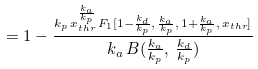Convert formula to latex. <formula><loc_0><loc_0><loc_500><loc_500>= 1 - \frac { _ { k _ { p } \, x _ { t h r } ^ { \frac { k _ { a } } { k _ { p } } } \, F _ { 1 } [ 1 - \frac { k _ { d } } { k _ { p } } , \, \frac { k _ { a } } { k _ { p } } , \, 1 + \frac { k _ { a } } { k _ { p } } , \, x _ { t h r } ] } } { k _ { a } \, B ( \frac { k _ { a } } { k _ { p } } , \, \frac { k _ { d } } { k _ { p } } ) }</formula> 